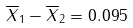<formula> <loc_0><loc_0><loc_500><loc_500>\overline { X } _ { 1 } - \overline { X } _ { 2 } = 0 . 0 9 5</formula> 